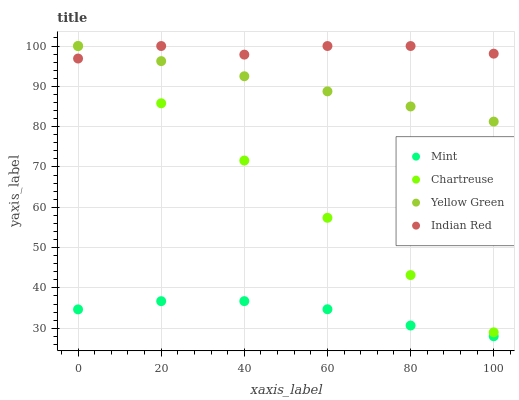Does Mint have the minimum area under the curve?
Answer yes or no. Yes. Does Indian Red have the maximum area under the curve?
Answer yes or no. Yes. Does Yellow Green have the minimum area under the curve?
Answer yes or no. No. Does Yellow Green have the maximum area under the curve?
Answer yes or no. No. Is Chartreuse the smoothest?
Answer yes or no. Yes. Is Indian Red the roughest?
Answer yes or no. Yes. Is Mint the smoothest?
Answer yes or no. No. Is Mint the roughest?
Answer yes or no. No. Does Mint have the lowest value?
Answer yes or no. Yes. Does Yellow Green have the lowest value?
Answer yes or no. No. Does Indian Red have the highest value?
Answer yes or no. Yes. Does Mint have the highest value?
Answer yes or no. No. Is Mint less than Indian Red?
Answer yes or no. Yes. Is Indian Red greater than Mint?
Answer yes or no. Yes. Does Chartreuse intersect Indian Red?
Answer yes or no. Yes. Is Chartreuse less than Indian Red?
Answer yes or no. No. Is Chartreuse greater than Indian Red?
Answer yes or no. No. Does Mint intersect Indian Red?
Answer yes or no. No. 